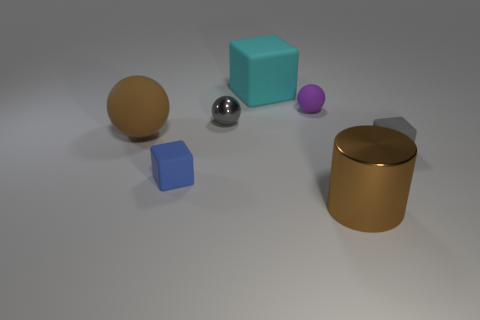Subtract 1 balls. How many balls are left? 2 Subtract all small balls. How many balls are left? 1 Subtract all blocks. How many objects are left? 4 Add 2 purple matte cylinders. How many objects exist? 9 Add 5 blue objects. How many blue objects exist? 6 Subtract 0 gray cylinders. How many objects are left? 7 Subtract all big rubber balls. Subtract all tiny yellow rubber cylinders. How many objects are left? 6 Add 5 brown metal objects. How many brown metal objects are left? 6 